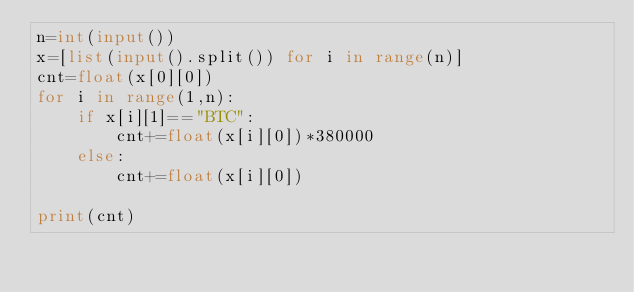Convert code to text. <code><loc_0><loc_0><loc_500><loc_500><_Python_>n=int(input())
x=[list(input().split()) for i in range(n)]
cnt=float(x[0][0])
for i in range(1,n):
    if x[i][1]=="BTC":
        cnt+=float(x[i][0])*380000
    else:
        cnt+=float(x[i][0])

print(cnt)</code> 